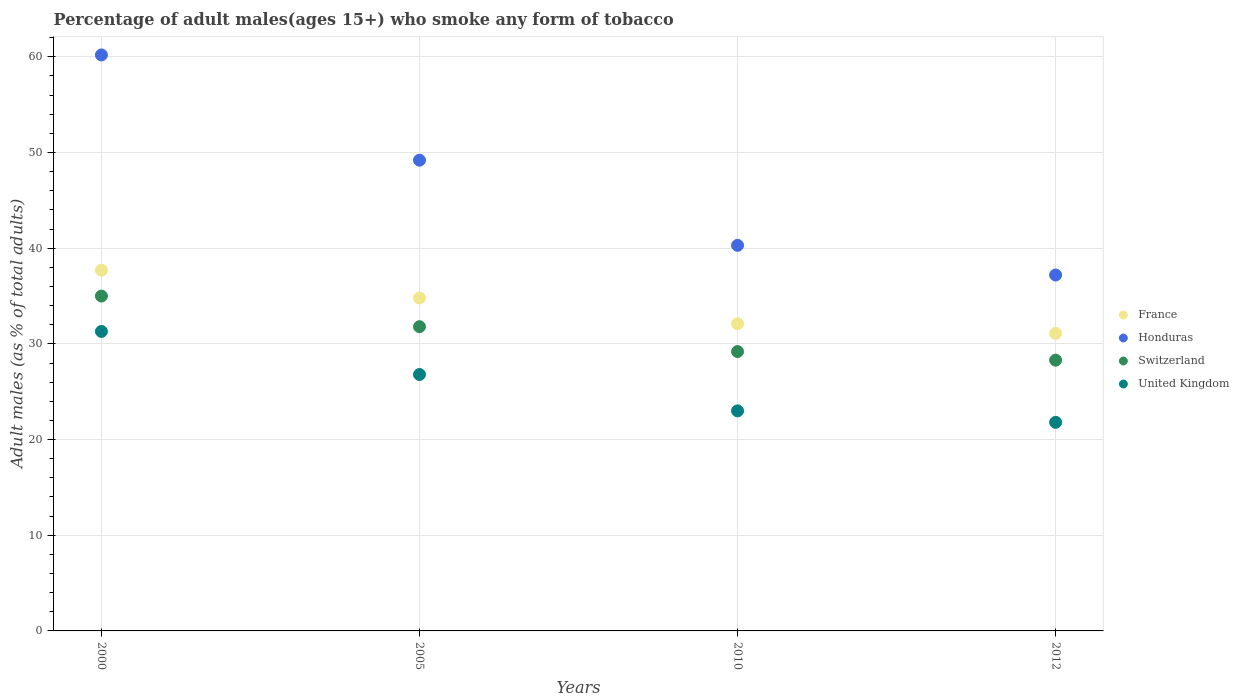How many different coloured dotlines are there?
Offer a terse response. 4. Is the number of dotlines equal to the number of legend labels?
Provide a succinct answer. Yes. What is the percentage of adult males who smoke in Switzerland in 2005?
Make the answer very short. 31.8. Across all years, what is the maximum percentage of adult males who smoke in United Kingdom?
Your answer should be very brief. 31.3. Across all years, what is the minimum percentage of adult males who smoke in Honduras?
Ensure brevity in your answer.  37.2. In which year was the percentage of adult males who smoke in United Kingdom minimum?
Your answer should be very brief. 2012. What is the total percentage of adult males who smoke in Switzerland in the graph?
Give a very brief answer. 124.3. What is the difference between the percentage of adult males who smoke in United Kingdom in 2000 and the percentage of adult males who smoke in Switzerland in 2010?
Provide a succinct answer. 2.1. What is the average percentage of adult males who smoke in United Kingdom per year?
Provide a short and direct response. 25.72. In the year 2010, what is the difference between the percentage of adult males who smoke in France and percentage of adult males who smoke in Switzerland?
Your response must be concise. 2.9. In how many years, is the percentage of adult males who smoke in Honduras greater than 28 %?
Offer a terse response. 4. What is the ratio of the percentage of adult males who smoke in United Kingdom in 2000 to that in 2012?
Offer a very short reply. 1.44. What is the difference between the highest and the second highest percentage of adult males who smoke in Switzerland?
Your answer should be very brief. 3.2. What is the difference between the highest and the lowest percentage of adult males who smoke in Switzerland?
Offer a very short reply. 6.7. In how many years, is the percentage of adult males who smoke in United Kingdom greater than the average percentage of adult males who smoke in United Kingdom taken over all years?
Provide a short and direct response. 2. Is the sum of the percentage of adult males who smoke in Honduras in 2000 and 2012 greater than the maximum percentage of adult males who smoke in France across all years?
Provide a succinct answer. Yes. Is it the case that in every year, the sum of the percentage of adult males who smoke in Switzerland and percentage of adult males who smoke in France  is greater than the percentage of adult males who smoke in Honduras?
Offer a terse response. Yes. How many years are there in the graph?
Your response must be concise. 4. Where does the legend appear in the graph?
Provide a succinct answer. Center right. How many legend labels are there?
Ensure brevity in your answer.  4. What is the title of the graph?
Provide a succinct answer. Percentage of adult males(ages 15+) who smoke any form of tobacco. Does "Burundi" appear as one of the legend labels in the graph?
Offer a terse response. No. What is the label or title of the Y-axis?
Offer a very short reply. Adult males (as % of total adults). What is the Adult males (as % of total adults) in France in 2000?
Offer a very short reply. 37.7. What is the Adult males (as % of total adults) in Honduras in 2000?
Provide a succinct answer. 60.2. What is the Adult males (as % of total adults) of Switzerland in 2000?
Offer a terse response. 35. What is the Adult males (as % of total adults) of United Kingdom in 2000?
Ensure brevity in your answer.  31.3. What is the Adult males (as % of total adults) of France in 2005?
Your answer should be compact. 34.8. What is the Adult males (as % of total adults) of Honduras in 2005?
Your answer should be compact. 49.2. What is the Adult males (as % of total adults) of Switzerland in 2005?
Your response must be concise. 31.8. What is the Adult males (as % of total adults) of United Kingdom in 2005?
Your response must be concise. 26.8. What is the Adult males (as % of total adults) in France in 2010?
Your response must be concise. 32.1. What is the Adult males (as % of total adults) in Honduras in 2010?
Ensure brevity in your answer.  40.3. What is the Adult males (as % of total adults) in Switzerland in 2010?
Make the answer very short. 29.2. What is the Adult males (as % of total adults) of United Kingdom in 2010?
Make the answer very short. 23. What is the Adult males (as % of total adults) in France in 2012?
Provide a short and direct response. 31.1. What is the Adult males (as % of total adults) of Honduras in 2012?
Provide a succinct answer. 37.2. What is the Adult males (as % of total adults) of Switzerland in 2012?
Ensure brevity in your answer.  28.3. What is the Adult males (as % of total adults) of United Kingdom in 2012?
Your response must be concise. 21.8. Across all years, what is the maximum Adult males (as % of total adults) of France?
Make the answer very short. 37.7. Across all years, what is the maximum Adult males (as % of total adults) of Honduras?
Offer a very short reply. 60.2. Across all years, what is the maximum Adult males (as % of total adults) of Switzerland?
Keep it short and to the point. 35. Across all years, what is the maximum Adult males (as % of total adults) in United Kingdom?
Offer a terse response. 31.3. Across all years, what is the minimum Adult males (as % of total adults) of France?
Your answer should be compact. 31.1. Across all years, what is the minimum Adult males (as % of total adults) of Honduras?
Your answer should be very brief. 37.2. Across all years, what is the minimum Adult males (as % of total adults) in Switzerland?
Provide a succinct answer. 28.3. Across all years, what is the minimum Adult males (as % of total adults) in United Kingdom?
Make the answer very short. 21.8. What is the total Adult males (as % of total adults) of France in the graph?
Make the answer very short. 135.7. What is the total Adult males (as % of total adults) of Honduras in the graph?
Ensure brevity in your answer.  186.9. What is the total Adult males (as % of total adults) in Switzerland in the graph?
Keep it short and to the point. 124.3. What is the total Adult males (as % of total adults) of United Kingdom in the graph?
Your answer should be compact. 102.9. What is the difference between the Adult males (as % of total adults) in Honduras in 2000 and that in 2005?
Offer a terse response. 11. What is the difference between the Adult males (as % of total adults) in Switzerland in 2000 and that in 2005?
Make the answer very short. 3.2. What is the difference between the Adult males (as % of total adults) in United Kingdom in 2000 and that in 2010?
Give a very brief answer. 8.3. What is the difference between the Adult males (as % of total adults) of France in 2000 and that in 2012?
Give a very brief answer. 6.6. What is the difference between the Adult males (as % of total adults) of Switzerland in 2000 and that in 2012?
Provide a short and direct response. 6.7. What is the difference between the Adult males (as % of total adults) of Honduras in 2005 and that in 2010?
Your answer should be very brief. 8.9. What is the difference between the Adult males (as % of total adults) of France in 2005 and that in 2012?
Provide a succinct answer. 3.7. What is the difference between the Adult males (as % of total adults) of Honduras in 2005 and that in 2012?
Provide a succinct answer. 12. What is the difference between the Adult males (as % of total adults) in France in 2010 and that in 2012?
Your answer should be compact. 1. What is the difference between the Adult males (as % of total adults) in Honduras in 2010 and that in 2012?
Your response must be concise. 3.1. What is the difference between the Adult males (as % of total adults) of France in 2000 and the Adult males (as % of total adults) of Honduras in 2005?
Offer a very short reply. -11.5. What is the difference between the Adult males (as % of total adults) in Honduras in 2000 and the Adult males (as % of total adults) in Switzerland in 2005?
Your answer should be compact. 28.4. What is the difference between the Adult males (as % of total adults) of Honduras in 2000 and the Adult males (as % of total adults) of United Kingdom in 2005?
Your response must be concise. 33.4. What is the difference between the Adult males (as % of total adults) of France in 2000 and the Adult males (as % of total adults) of Honduras in 2010?
Ensure brevity in your answer.  -2.6. What is the difference between the Adult males (as % of total adults) in France in 2000 and the Adult males (as % of total adults) in Switzerland in 2010?
Provide a succinct answer. 8.5. What is the difference between the Adult males (as % of total adults) of France in 2000 and the Adult males (as % of total adults) of United Kingdom in 2010?
Your answer should be very brief. 14.7. What is the difference between the Adult males (as % of total adults) of Honduras in 2000 and the Adult males (as % of total adults) of United Kingdom in 2010?
Your response must be concise. 37.2. What is the difference between the Adult males (as % of total adults) of Switzerland in 2000 and the Adult males (as % of total adults) of United Kingdom in 2010?
Your answer should be very brief. 12. What is the difference between the Adult males (as % of total adults) of France in 2000 and the Adult males (as % of total adults) of Switzerland in 2012?
Offer a terse response. 9.4. What is the difference between the Adult males (as % of total adults) in Honduras in 2000 and the Adult males (as % of total adults) in Switzerland in 2012?
Provide a short and direct response. 31.9. What is the difference between the Adult males (as % of total adults) in Honduras in 2000 and the Adult males (as % of total adults) in United Kingdom in 2012?
Your answer should be very brief. 38.4. What is the difference between the Adult males (as % of total adults) of France in 2005 and the Adult males (as % of total adults) of Switzerland in 2010?
Your answer should be compact. 5.6. What is the difference between the Adult males (as % of total adults) of Honduras in 2005 and the Adult males (as % of total adults) of United Kingdom in 2010?
Make the answer very short. 26.2. What is the difference between the Adult males (as % of total adults) in Switzerland in 2005 and the Adult males (as % of total adults) in United Kingdom in 2010?
Your response must be concise. 8.8. What is the difference between the Adult males (as % of total adults) in France in 2005 and the Adult males (as % of total adults) in Honduras in 2012?
Provide a succinct answer. -2.4. What is the difference between the Adult males (as % of total adults) in France in 2005 and the Adult males (as % of total adults) in Switzerland in 2012?
Give a very brief answer. 6.5. What is the difference between the Adult males (as % of total adults) of Honduras in 2005 and the Adult males (as % of total adults) of Switzerland in 2012?
Offer a very short reply. 20.9. What is the difference between the Adult males (as % of total adults) in Honduras in 2005 and the Adult males (as % of total adults) in United Kingdom in 2012?
Provide a short and direct response. 27.4. What is the difference between the Adult males (as % of total adults) in Switzerland in 2005 and the Adult males (as % of total adults) in United Kingdom in 2012?
Your answer should be compact. 10. What is the difference between the Adult males (as % of total adults) of France in 2010 and the Adult males (as % of total adults) of Honduras in 2012?
Provide a succinct answer. -5.1. What is the difference between the Adult males (as % of total adults) in France in 2010 and the Adult males (as % of total adults) in Switzerland in 2012?
Provide a succinct answer. 3.8. What is the difference between the Adult males (as % of total adults) of Honduras in 2010 and the Adult males (as % of total adults) of Switzerland in 2012?
Make the answer very short. 12. What is the difference between the Adult males (as % of total adults) in Honduras in 2010 and the Adult males (as % of total adults) in United Kingdom in 2012?
Provide a short and direct response. 18.5. What is the difference between the Adult males (as % of total adults) of Switzerland in 2010 and the Adult males (as % of total adults) of United Kingdom in 2012?
Give a very brief answer. 7.4. What is the average Adult males (as % of total adults) of France per year?
Provide a short and direct response. 33.92. What is the average Adult males (as % of total adults) in Honduras per year?
Your response must be concise. 46.73. What is the average Adult males (as % of total adults) of Switzerland per year?
Ensure brevity in your answer.  31.07. What is the average Adult males (as % of total adults) in United Kingdom per year?
Make the answer very short. 25.73. In the year 2000, what is the difference between the Adult males (as % of total adults) in France and Adult males (as % of total adults) in Honduras?
Ensure brevity in your answer.  -22.5. In the year 2000, what is the difference between the Adult males (as % of total adults) in Honduras and Adult males (as % of total adults) in Switzerland?
Offer a terse response. 25.2. In the year 2000, what is the difference between the Adult males (as % of total adults) in Honduras and Adult males (as % of total adults) in United Kingdom?
Your answer should be very brief. 28.9. In the year 2000, what is the difference between the Adult males (as % of total adults) in Switzerland and Adult males (as % of total adults) in United Kingdom?
Make the answer very short. 3.7. In the year 2005, what is the difference between the Adult males (as % of total adults) in France and Adult males (as % of total adults) in Honduras?
Ensure brevity in your answer.  -14.4. In the year 2005, what is the difference between the Adult males (as % of total adults) in Honduras and Adult males (as % of total adults) in Switzerland?
Provide a succinct answer. 17.4. In the year 2005, what is the difference between the Adult males (as % of total adults) of Honduras and Adult males (as % of total adults) of United Kingdom?
Offer a very short reply. 22.4. In the year 2005, what is the difference between the Adult males (as % of total adults) of Switzerland and Adult males (as % of total adults) of United Kingdom?
Give a very brief answer. 5. In the year 2010, what is the difference between the Adult males (as % of total adults) of Honduras and Adult males (as % of total adults) of Switzerland?
Give a very brief answer. 11.1. In the year 2010, what is the difference between the Adult males (as % of total adults) of Switzerland and Adult males (as % of total adults) of United Kingdom?
Provide a succinct answer. 6.2. In the year 2012, what is the difference between the Adult males (as % of total adults) in Honduras and Adult males (as % of total adults) in Switzerland?
Your answer should be compact. 8.9. In the year 2012, what is the difference between the Adult males (as % of total adults) of Honduras and Adult males (as % of total adults) of United Kingdom?
Your answer should be very brief. 15.4. What is the ratio of the Adult males (as % of total adults) of France in 2000 to that in 2005?
Keep it short and to the point. 1.08. What is the ratio of the Adult males (as % of total adults) in Honduras in 2000 to that in 2005?
Ensure brevity in your answer.  1.22. What is the ratio of the Adult males (as % of total adults) in Switzerland in 2000 to that in 2005?
Offer a terse response. 1.1. What is the ratio of the Adult males (as % of total adults) in United Kingdom in 2000 to that in 2005?
Ensure brevity in your answer.  1.17. What is the ratio of the Adult males (as % of total adults) in France in 2000 to that in 2010?
Keep it short and to the point. 1.17. What is the ratio of the Adult males (as % of total adults) in Honduras in 2000 to that in 2010?
Your answer should be very brief. 1.49. What is the ratio of the Adult males (as % of total adults) of Switzerland in 2000 to that in 2010?
Give a very brief answer. 1.2. What is the ratio of the Adult males (as % of total adults) in United Kingdom in 2000 to that in 2010?
Offer a terse response. 1.36. What is the ratio of the Adult males (as % of total adults) in France in 2000 to that in 2012?
Your answer should be compact. 1.21. What is the ratio of the Adult males (as % of total adults) in Honduras in 2000 to that in 2012?
Keep it short and to the point. 1.62. What is the ratio of the Adult males (as % of total adults) of Switzerland in 2000 to that in 2012?
Keep it short and to the point. 1.24. What is the ratio of the Adult males (as % of total adults) of United Kingdom in 2000 to that in 2012?
Offer a very short reply. 1.44. What is the ratio of the Adult males (as % of total adults) in France in 2005 to that in 2010?
Your answer should be very brief. 1.08. What is the ratio of the Adult males (as % of total adults) of Honduras in 2005 to that in 2010?
Provide a short and direct response. 1.22. What is the ratio of the Adult males (as % of total adults) of Switzerland in 2005 to that in 2010?
Offer a terse response. 1.09. What is the ratio of the Adult males (as % of total adults) in United Kingdom in 2005 to that in 2010?
Your answer should be very brief. 1.17. What is the ratio of the Adult males (as % of total adults) in France in 2005 to that in 2012?
Your response must be concise. 1.12. What is the ratio of the Adult males (as % of total adults) in Honduras in 2005 to that in 2012?
Provide a short and direct response. 1.32. What is the ratio of the Adult males (as % of total adults) of Switzerland in 2005 to that in 2012?
Provide a succinct answer. 1.12. What is the ratio of the Adult males (as % of total adults) of United Kingdom in 2005 to that in 2012?
Offer a very short reply. 1.23. What is the ratio of the Adult males (as % of total adults) in France in 2010 to that in 2012?
Keep it short and to the point. 1.03. What is the ratio of the Adult males (as % of total adults) of Switzerland in 2010 to that in 2012?
Offer a terse response. 1.03. What is the ratio of the Adult males (as % of total adults) in United Kingdom in 2010 to that in 2012?
Make the answer very short. 1.05. What is the difference between the highest and the second highest Adult males (as % of total adults) in France?
Offer a very short reply. 2.9. What is the difference between the highest and the second highest Adult males (as % of total adults) in Switzerland?
Make the answer very short. 3.2. What is the difference between the highest and the second highest Adult males (as % of total adults) in United Kingdom?
Make the answer very short. 4.5. What is the difference between the highest and the lowest Adult males (as % of total adults) in Switzerland?
Give a very brief answer. 6.7. What is the difference between the highest and the lowest Adult males (as % of total adults) in United Kingdom?
Keep it short and to the point. 9.5. 